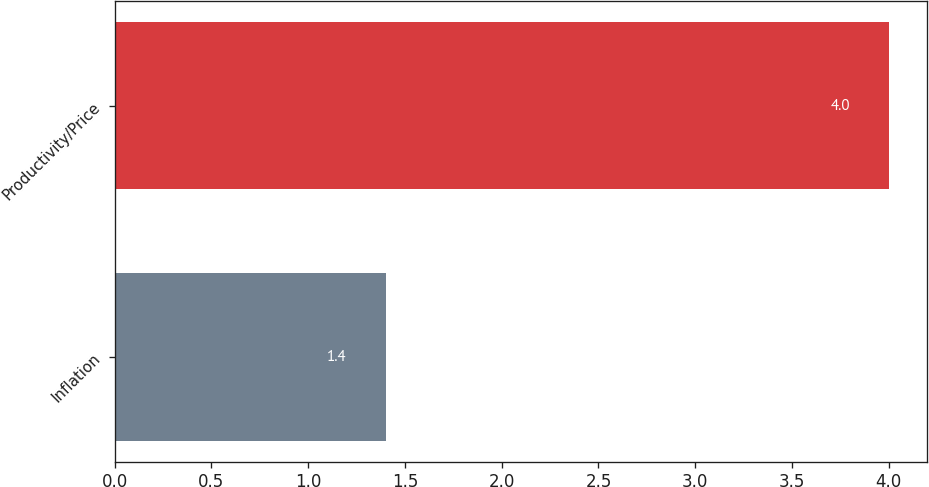Convert chart. <chart><loc_0><loc_0><loc_500><loc_500><bar_chart><fcel>Inflation<fcel>Productivity/Price<nl><fcel>1.4<fcel>4<nl></chart> 